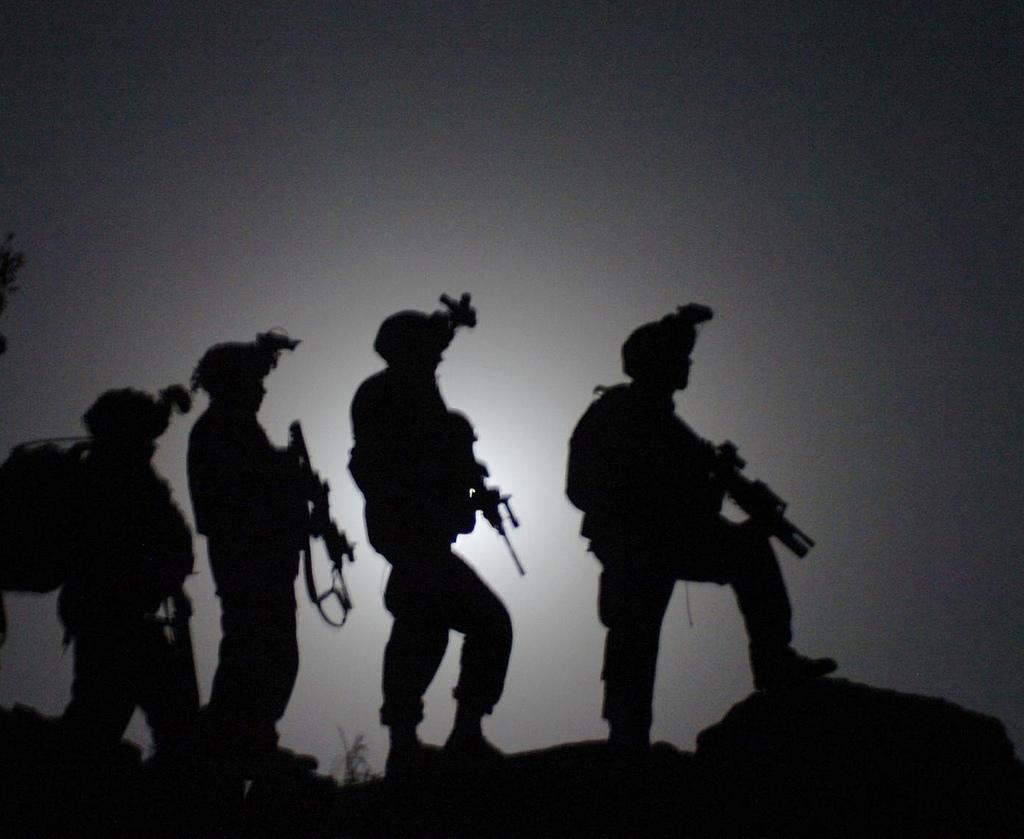What type of people can be seen in the image? There are soldiers in the image. What are the soldiers doing in the image? The soldiers are standing in the image. What are the soldiers holding in their hands? The soldiers are holding guns in their hands. What can be seen at the bottom of the image? There are rocks at the bottom of the image. What type of vegetation is present in the image? There is a plant in the image. What type of locket is hanging from the soldier's neck in the image? There is no locket visible in the image; the soldiers are holding guns and standing. 